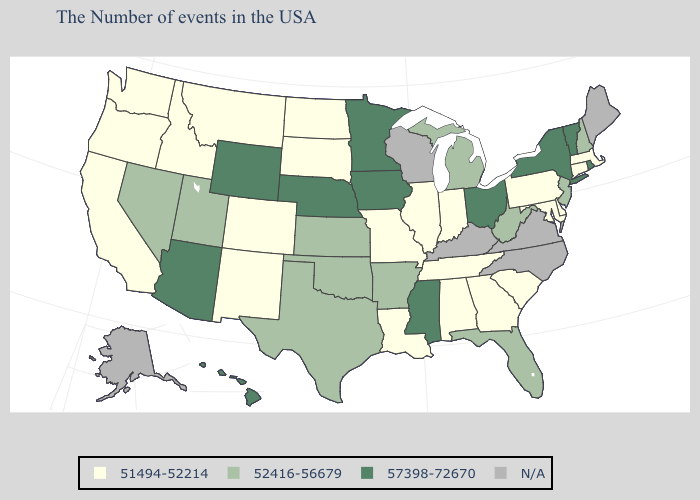What is the lowest value in the USA?
Concise answer only. 51494-52214. What is the highest value in the West ?
Write a very short answer. 57398-72670. What is the highest value in the USA?
Short answer required. 57398-72670. Name the states that have a value in the range 52416-56679?
Give a very brief answer. New Hampshire, New Jersey, West Virginia, Florida, Michigan, Arkansas, Kansas, Oklahoma, Texas, Utah, Nevada. Does New York have the lowest value in the USA?
Quick response, please. No. Name the states that have a value in the range 57398-72670?
Quick response, please. Rhode Island, Vermont, New York, Ohio, Mississippi, Minnesota, Iowa, Nebraska, Wyoming, Arizona, Hawaii. Which states have the lowest value in the Northeast?
Short answer required. Massachusetts, Connecticut, Pennsylvania. Name the states that have a value in the range 51494-52214?
Answer briefly. Massachusetts, Connecticut, Delaware, Maryland, Pennsylvania, South Carolina, Georgia, Indiana, Alabama, Tennessee, Illinois, Louisiana, Missouri, South Dakota, North Dakota, Colorado, New Mexico, Montana, Idaho, California, Washington, Oregon. Does Vermont have the lowest value in the USA?
Concise answer only. No. Does North Dakota have the lowest value in the USA?
Write a very short answer. Yes. What is the value of Maine?
Be succinct. N/A. Name the states that have a value in the range N/A?
Be succinct. Maine, Virginia, North Carolina, Kentucky, Wisconsin, Alaska. 